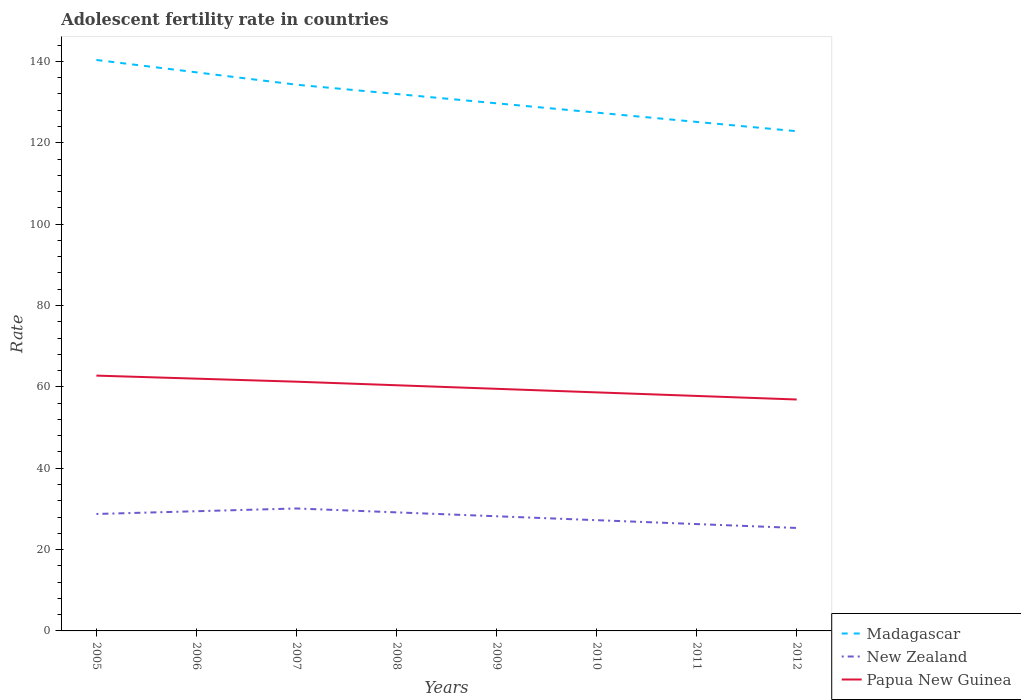Across all years, what is the maximum adolescent fertility rate in New Zealand?
Ensure brevity in your answer.  25.31. In which year was the adolescent fertility rate in Madagascar maximum?
Ensure brevity in your answer.  2012. What is the total adolescent fertility rate in Papua New Guinea in the graph?
Give a very brief answer. 5. What is the difference between the highest and the second highest adolescent fertility rate in Papua New Guinea?
Give a very brief answer. 5.87. Is the adolescent fertility rate in Papua New Guinea strictly greater than the adolescent fertility rate in Madagascar over the years?
Make the answer very short. Yes. How many years are there in the graph?
Make the answer very short. 8. Are the values on the major ticks of Y-axis written in scientific E-notation?
Offer a very short reply. No. Does the graph contain any zero values?
Make the answer very short. No. Does the graph contain grids?
Offer a very short reply. No. Where does the legend appear in the graph?
Provide a succinct answer. Bottom right. How many legend labels are there?
Your response must be concise. 3. How are the legend labels stacked?
Give a very brief answer. Vertical. What is the title of the graph?
Provide a succinct answer. Adolescent fertility rate in countries. What is the label or title of the Y-axis?
Give a very brief answer. Rate. What is the Rate of Madagascar in 2005?
Provide a short and direct response. 140.35. What is the Rate of New Zealand in 2005?
Make the answer very short. 28.75. What is the Rate in Papua New Guinea in 2005?
Offer a very short reply. 62.76. What is the Rate of Madagascar in 2006?
Ensure brevity in your answer.  137.31. What is the Rate of New Zealand in 2006?
Provide a succinct answer. 29.43. What is the Rate of Papua New Guinea in 2006?
Ensure brevity in your answer.  62.02. What is the Rate in Madagascar in 2007?
Give a very brief answer. 134.27. What is the Rate of New Zealand in 2007?
Ensure brevity in your answer.  30.1. What is the Rate of Papua New Guinea in 2007?
Give a very brief answer. 61.27. What is the Rate of Madagascar in 2008?
Provide a succinct answer. 131.99. What is the Rate of New Zealand in 2008?
Your answer should be very brief. 29.14. What is the Rate in Papua New Guinea in 2008?
Offer a terse response. 60.39. What is the Rate in Madagascar in 2009?
Provide a short and direct response. 129.7. What is the Rate of New Zealand in 2009?
Your response must be concise. 28.18. What is the Rate of Papua New Guinea in 2009?
Give a very brief answer. 59.52. What is the Rate of Madagascar in 2010?
Provide a short and direct response. 127.41. What is the Rate of New Zealand in 2010?
Your answer should be very brief. 27.23. What is the Rate in Papua New Guinea in 2010?
Offer a terse response. 58.64. What is the Rate of Madagascar in 2011?
Provide a succinct answer. 125.13. What is the Rate of New Zealand in 2011?
Your answer should be very brief. 26.27. What is the Rate of Papua New Guinea in 2011?
Offer a terse response. 57.76. What is the Rate of Madagascar in 2012?
Make the answer very short. 122.84. What is the Rate of New Zealand in 2012?
Ensure brevity in your answer.  25.31. What is the Rate in Papua New Guinea in 2012?
Your answer should be very brief. 56.89. Across all years, what is the maximum Rate of Madagascar?
Give a very brief answer. 140.35. Across all years, what is the maximum Rate in New Zealand?
Your response must be concise. 30.1. Across all years, what is the maximum Rate of Papua New Guinea?
Provide a short and direct response. 62.76. Across all years, what is the minimum Rate in Madagascar?
Offer a terse response. 122.84. Across all years, what is the minimum Rate of New Zealand?
Keep it short and to the point. 25.31. Across all years, what is the minimum Rate of Papua New Guinea?
Your response must be concise. 56.89. What is the total Rate in Madagascar in the graph?
Your response must be concise. 1049.02. What is the total Rate of New Zealand in the graph?
Offer a terse response. 224.4. What is the total Rate of Papua New Guinea in the graph?
Keep it short and to the point. 479.25. What is the difference between the Rate in Madagascar in 2005 and that in 2006?
Offer a terse response. 3.04. What is the difference between the Rate in New Zealand in 2005 and that in 2006?
Ensure brevity in your answer.  -0.68. What is the difference between the Rate in Papua New Guinea in 2005 and that in 2006?
Your answer should be compact. 0.75. What is the difference between the Rate in Madagascar in 2005 and that in 2007?
Keep it short and to the point. 6.08. What is the difference between the Rate in New Zealand in 2005 and that in 2007?
Make the answer very short. -1.35. What is the difference between the Rate in Papua New Guinea in 2005 and that in 2007?
Provide a succinct answer. 1.49. What is the difference between the Rate in Madagascar in 2005 and that in 2008?
Provide a succinct answer. 8.37. What is the difference between the Rate in New Zealand in 2005 and that in 2008?
Offer a very short reply. -0.39. What is the difference between the Rate of Papua New Guinea in 2005 and that in 2008?
Make the answer very short. 2.37. What is the difference between the Rate in Madagascar in 2005 and that in 2009?
Offer a very short reply. 10.65. What is the difference between the Rate in New Zealand in 2005 and that in 2009?
Your answer should be compact. 0.56. What is the difference between the Rate of Papua New Guinea in 2005 and that in 2009?
Give a very brief answer. 3.25. What is the difference between the Rate of Madagascar in 2005 and that in 2010?
Your answer should be compact. 12.94. What is the difference between the Rate in New Zealand in 2005 and that in 2010?
Make the answer very short. 1.52. What is the difference between the Rate in Papua New Guinea in 2005 and that in 2010?
Your answer should be very brief. 4.12. What is the difference between the Rate in Madagascar in 2005 and that in 2011?
Ensure brevity in your answer.  15.23. What is the difference between the Rate of New Zealand in 2005 and that in 2011?
Offer a terse response. 2.48. What is the difference between the Rate in Papua New Guinea in 2005 and that in 2011?
Give a very brief answer. 5. What is the difference between the Rate in Madagascar in 2005 and that in 2012?
Ensure brevity in your answer.  17.51. What is the difference between the Rate in New Zealand in 2005 and that in 2012?
Keep it short and to the point. 3.44. What is the difference between the Rate of Papua New Guinea in 2005 and that in 2012?
Give a very brief answer. 5.87. What is the difference between the Rate of Madagascar in 2006 and that in 2007?
Ensure brevity in your answer.  3.04. What is the difference between the Rate in New Zealand in 2006 and that in 2007?
Provide a short and direct response. -0.68. What is the difference between the Rate of Papua New Guinea in 2006 and that in 2007?
Make the answer very short. 0.75. What is the difference between the Rate in Madagascar in 2006 and that in 2008?
Your answer should be very brief. 5.33. What is the difference between the Rate of New Zealand in 2006 and that in 2008?
Provide a short and direct response. 0.28. What is the difference between the Rate of Papua New Guinea in 2006 and that in 2008?
Give a very brief answer. 1.62. What is the difference between the Rate in Madagascar in 2006 and that in 2009?
Your response must be concise. 7.61. What is the difference between the Rate in New Zealand in 2006 and that in 2009?
Your answer should be very brief. 1.24. What is the difference between the Rate in Papua New Guinea in 2006 and that in 2009?
Your answer should be very brief. 2.5. What is the difference between the Rate in Madagascar in 2006 and that in 2010?
Ensure brevity in your answer.  9.9. What is the difference between the Rate of New Zealand in 2006 and that in 2010?
Your answer should be very brief. 2.2. What is the difference between the Rate in Papua New Guinea in 2006 and that in 2010?
Offer a very short reply. 3.37. What is the difference between the Rate of Madagascar in 2006 and that in 2011?
Ensure brevity in your answer.  12.19. What is the difference between the Rate in New Zealand in 2006 and that in 2011?
Your response must be concise. 3.16. What is the difference between the Rate of Papua New Guinea in 2006 and that in 2011?
Keep it short and to the point. 4.25. What is the difference between the Rate of Madagascar in 2006 and that in 2012?
Your answer should be very brief. 14.47. What is the difference between the Rate in New Zealand in 2006 and that in 2012?
Provide a succinct answer. 4.12. What is the difference between the Rate of Papua New Guinea in 2006 and that in 2012?
Provide a succinct answer. 5.13. What is the difference between the Rate of Madagascar in 2007 and that in 2008?
Your answer should be very brief. 2.29. What is the difference between the Rate in New Zealand in 2007 and that in 2008?
Your answer should be compact. 0.96. What is the difference between the Rate of Papua New Guinea in 2007 and that in 2008?
Your answer should be very brief. 0.88. What is the difference between the Rate in Madagascar in 2007 and that in 2009?
Your response must be concise. 4.57. What is the difference between the Rate in New Zealand in 2007 and that in 2009?
Ensure brevity in your answer.  1.92. What is the difference between the Rate in Papua New Guinea in 2007 and that in 2009?
Your response must be concise. 1.75. What is the difference between the Rate in Madagascar in 2007 and that in 2010?
Your response must be concise. 6.86. What is the difference between the Rate in New Zealand in 2007 and that in 2010?
Make the answer very short. 2.88. What is the difference between the Rate in Papua New Guinea in 2007 and that in 2010?
Your response must be concise. 2.63. What is the difference between the Rate in Madagascar in 2007 and that in 2011?
Keep it short and to the point. 9.15. What is the difference between the Rate of New Zealand in 2007 and that in 2011?
Provide a succinct answer. 3.83. What is the difference between the Rate of Papua New Guinea in 2007 and that in 2011?
Make the answer very short. 3.5. What is the difference between the Rate of Madagascar in 2007 and that in 2012?
Provide a short and direct response. 11.43. What is the difference between the Rate in New Zealand in 2007 and that in 2012?
Offer a terse response. 4.79. What is the difference between the Rate of Papua New Guinea in 2007 and that in 2012?
Ensure brevity in your answer.  4.38. What is the difference between the Rate of Madagascar in 2008 and that in 2009?
Keep it short and to the point. 2.29. What is the difference between the Rate in New Zealand in 2008 and that in 2009?
Your answer should be compact. 0.96. What is the difference between the Rate of Papua New Guinea in 2008 and that in 2009?
Provide a succinct answer. 0.88. What is the difference between the Rate in Madagascar in 2008 and that in 2010?
Keep it short and to the point. 4.57. What is the difference between the Rate of New Zealand in 2008 and that in 2010?
Your response must be concise. 1.92. What is the difference between the Rate in Papua New Guinea in 2008 and that in 2010?
Your answer should be very brief. 1.75. What is the difference between the Rate of Madagascar in 2008 and that in 2011?
Make the answer very short. 6.86. What is the difference between the Rate of New Zealand in 2008 and that in 2011?
Give a very brief answer. 2.88. What is the difference between the Rate in Papua New Guinea in 2008 and that in 2011?
Provide a succinct answer. 2.63. What is the difference between the Rate in Madagascar in 2008 and that in 2012?
Keep it short and to the point. 9.15. What is the difference between the Rate in New Zealand in 2008 and that in 2012?
Your response must be concise. 3.83. What is the difference between the Rate in Papua New Guinea in 2008 and that in 2012?
Offer a very short reply. 3.5. What is the difference between the Rate of Madagascar in 2009 and that in 2010?
Offer a very short reply. 2.29. What is the difference between the Rate in New Zealand in 2009 and that in 2010?
Your response must be concise. 0.96. What is the difference between the Rate of Papua New Guinea in 2009 and that in 2010?
Give a very brief answer. 0.88. What is the difference between the Rate of Madagascar in 2009 and that in 2011?
Offer a very short reply. 4.57. What is the difference between the Rate in New Zealand in 2009 and that in 2011?
Offer a terse response. 1.92. What is the difference between the Rate of Papua New Guinea in 2009 and that in 2011?
Offer a very short reply. 1.75. What is the difference between the Rate in Madagascar in 2009 and that in 2012?
Provide a succinct answer. 6.86. What is the difference between the Rate in New Zealand in 2009 and that in 2012?
Offer a terse response. 2.88. What is the difference between the Rate of Papua New Guinea in 2009 and that in 2012?
Your answer should be compact. 2.63. What is the difference between the Rate in Madagascar in 2010 and that in 2011?
Keep it short and to the point. 2.29. What is the difference between the Rate of New Zealand in 2010 and that in 2011?
Keep it short and to the point. 0.96. What is the difference between the Rate in Papua New Guinea in 2010 and that in 2011?
Ensure brevity in your answer.  0.88. What is the difference between the Rate of Madagascar in 2010 and that in 2012?
Your answer should be compact. 4.57. What is the difference between the Rate in New Zealand in 2010 and that in 2012?
Make the answer very short. 1.92. What is the difference between the Rate in Papua New Guinea in 2010 and that in 2012?
Provide a succinct answer. 1.75. What is the difference between the Rate in Madagascar in 2011 and that in 2012?
Your answer should be very brief. 2.29. What is the difference between the Rate of New Zealand in 2011 and that in 2012?
Offer a very short reply. 0.96. What is the difference between the Rate of Papua New Guinea in 2011 and that in 2012?
Provide a short and direct response. 0.88. What is the difference between the Rate in Madagascar in 2005 and the Rate in New Zealand in 2006?
Ensure brevity in your answer.  110.93. What is the difference between the Rate of Madagascar in 2005 and the Rate of Papua New Guinea in 2006?
Give a very brief answer. 78.34. What is the difference between the Rate of New Zealand in 2005 and the Rate of Papua New Guinea in 2006?
Offer a terse response. -33.27. What is the difference between the Rate of Madagascar in 2005 and the Rate of New Zealand in 2007?
Give a very brief answer. 110.25. What is the difference between the Rate in Madagascar in 2005 and the Rate in Papua New Guinea in 2007?
Ensure brevity in your answer.  79.09. What is the difference between the Rate in New Zealand in 2005 and the Rate in Papua New Guinea in 2007?
Provide a succinct answer. -32.52. What is the difference between the Rate in Madagascar in 2005 and the Rate in New Zealand in 2008?
Your answer should be very brief. 111.21. What is the difference between the Rate of Madagascar in 2005 and the Rate of Papua New Guinea in 2008?
Your response must be concise. 79.96. What is the difference between the Rate of New Zealand in 2005 and the Rate of Papua New Guinea in 2008?
Make the answer very short. -31.64. What is the difference between the Rate of Madagascar in 2005 and the Rate of New Zealand in 2009?
Give a very brief answer. 112.17. What is the difference between the Rate of Madagascar in 2005 and the Rate of Papua New Guinea in 2009?
Offer a very short reply. 80.84. What is the difference between the Rate of New Zealand in 2005 and the Rate of Papua New Guinea in 2009?
Keep it short and to the point. -30.77. What is the difference between the Rate in Madagascar in 2005 and the Rate in New Zealand in 2010?
Ensure brevity in your answer.  113.13. What is the difference between the Rate of Madagascar in 2005 and the Rate of Papua New Guinea in 2010?
Offer a very short reply. 81.71. What is the difference between the Rate of New Zealand in 2005 and the Rate of Papua New Guinea in 2010?
Your response must be concise. -29.89. What is the difference between the Rate in Madagascar in 2005 and the Rate in New Zealand in 2011?
Your answer should be very brief. 114.09. What is the difference between the Rate of Madagascar in 2005 and the Rate of Papua New Guinea in 2011?
Offer a terse response. 82.59. What is the difference between the Rate in New Zealand in 2005 and the Rate in Papua New Guinea in 2011?
Keep it short and to the point. -29.02. What is the difference between the Rate in Madagascar in 2005 and the Rate in New Zealand in 2012?
Your response must be concise. 115.04. What is the difference between the Rate of Madagascar in 2005 and the Rate of Papua New Guinea in 2012?
Your response must be concise. 83.46. What is the difference between the Rate in New Zealand in 2005 and the Rate in Papua New Guinea in 2012?
Your answer should be very brief. -28.14. What is the difference between the Rate in Madagascar in 2006 and the Rate in New Zealand in 2007?
Your answer should be compact. 107.21. What is the difference between the Rate of Madagascar in 2006 and the Rate of Papua New Guinea in 2007?
Provide a succinct answer. 76.05. What is the difference between the Rate in New Zealand in 2006 and the Rate in Papua New Guinea in 2007?
Give a very brief answer. -31.84. What is the difference between the Rate in Madagascar in 2006 and the Rate in New Zealand in 2008?
Provide a succinct answer. 108.17. What is the difference between the Rate of Madagascar in 2006 and the Rate of Papua New Guinea in 2008?
Make the answer very short. 76.92. What is the difference between the Rate in New Zealand in 2006 and the Rate in Papua New Guinea in 2008?
Make the answer very short. -30.97. What is the difference between the Rate of Madagascar in 2006 and the Rate of New Zealand in 2009?
Ensure brevity in your answer.  109.13. What is the difference between the Rate of Madagascar in 2006 and the Rate of Papua New Guinea in 2009?
Provide a succinct answer. 77.8. What is the difference between the Rate of New Zealand in 2006 and the Rate of Papua New Guinea in 2009?
Provide a short and direct response. -30.09. What is the difference between the Rate in Madagascar in 2006 and the Rate in New Zealand in 2010?
Give a very brief answer. 110.09. What is the difference between the Rate of Madagascar in 2006 and the Rate of Papua New Guinea in 2010?
Your answer should be compact. 78.67. What is the difference between the Rate of New Zealand in 2006 and the Rate of Papua New Guinea in 2010?
Make the answer very short. -29.22. What is the difference between the Rate of Madagascar in 2006 and the Rate of New Zealand in 2011?
Offer a very short reply. 111.05. What is the difference between the Rate of Madagascar in 2006 and the Rate of Papua New Guinea in 2011?
Ensure brevity in your answer.  79.55. What is the difference between the Rate of New Zealand in 2006 and the Rate of Papua New Guinea in 2011?
Your answer should be very brief. -28.34. What is the difference between the Rate in Madagascar in 2006 and the Rate in New Zealand in 2012?
Your answer should be compact. 112. What is the difference between the Rate in Madagascar in 2006 and the Rate in Papua New Guinea in 2012?
Make the answer very short. 80.42. What is the difference between the Rate in New Zealand in 2006 and the Rate in Papua New Guinea in 2012?
Your answer should be very brief. -27.46. What is the difference between the Rate in Madagascar in 2007 and the Rate in New Zealand in 2008?
Keep it short and to the point. 105.13. What is the difference between the Rate in Madagascar in 2007 and the Rate in Papua New Guinea in 2008?
Make the answer very short. 73.88. What is the difference between the Rate in New Zealand in 2007 and the Rate in Papua New Guinea in 2008?
Your answer should be very brief. -30.29. What is the difference between the Rate in Madagascar in 2007 and the Rate in New Zealand in 2009?
Ensure brevity in your answer.  106.09. What is the difference between the Rate in Madagascar in 2007 and the Rate in Papua New Guinea in 2009?
Offer a very short reply. 74.76. What is the difference between the Rate of New Zealand in 2007 and the Rate of Papua New Guinea in 2009?
Make the answer very short. -29.42. What is the difference between the Rate of Madagascar in 2007 and the Rate of New Zealand in 2010?
Offer a terse response. 107.05. What is the difference between the Rate of Madagascar in 2007 and the Rate of Papua New Guinea in 2010?
Your response must be concise. 75.63. What is the difference between the Rate of New Zealand in 2007 and the Rate of Papua New Guinea in 2010?
Your answer should be compact. -28.54. What is the difference between the Rate of Madagascar in 2007 and the Rate of New Zealand in 2011?
Keep it short and to the point. 108.01. What is the difference between the Rate in Madagascar in 2007 and the Rate in Papua New Guinea in 2011?
Offer a terse response. 76.51. What is the difference between the Rate in New Zealand in 2007 and the Rate in Papua New Guinea in 2011?
Your response must be concise. -27.66. What is the difference between the Rate in Madagascar in 2007 and the Rate in New Zealand in 2012?
Your response must be concise. 108.97. What is the difference between the Rate of Madagascar in 2007 and the Rate of Papua New Guinea in 2012?
Your answer should be very brief. 77.39. What is the difference between the Rate of New Zealand in 2007 and the Rate of Papua New Guinea in 2012?
Make the answer very short. -26.79. What is the difference between the Rate in Madagascar in 2008 and the Rate in New Zealand in 2009?
Provide a short and direct response. 103.8. What is the difference between the Rate in Madagascar in 2008 and the Rate in Papua New Guinea in 2009?
Your response must be concise. 72.47. What is the difference between the Rate in New Zealand in 2008 and the Rate in Papua New Guinea in 2009?
Provide a short and direct response. -30.37. What is the difference between the Rate of Madagascar in 2008 and the Rate of New Zealand in 2010?
Make the answer very short. 104.76. What is the difference between the Rate in Madagascar in 2008 and the Rate in Papua New Guinea in 2010?
Your answer should be compact. 73.35. What is the difference between the Rate of New Zealand in 2008 and the Rate of Papua New Guinea in 2010?
Ensure brevity in your answer.  -29.5. What is the difference between the Rate in Madagascar in 2008 and the Rate in New Zealand in 2011?
Provide a short and direct response. 105.72. What is the difference between the Rate in Madagascar in 2008 and the Rate in Papua New Guinea in 2011?
Offer a very short reply. 74.22. What is the difference between the Rate of New Zealand in 2008 and the Rate of Papua New Guinea in 2011?
Your answer should be very brief. -28.62. What is the difference between the Rate of Madagascar in 2008 and the Rate of New Zealand in 2012?
Your answer should be very brief. 106.68. What is the difference between the Rate of Madagascar in 2008 and the Rate of Papua New Guinea in 2012?
Your response must be concise. 75.1. What is the difference between the Rate in New Zealand in 2008 and the Rate in Papua New Guinea in 2012?
Your answer should be very brief. -27.75. What is the difference between the Rate in Madagascar in 2009 and the Rate in New Zealand in 2010?
Offer a very short reply. 102.48. What is the difference between the Rate of Madagascar in 2009 and the Rate of Papua New Guinea in 2010?
Give a very brief answer. 71.06. What is the difference between the Rate of New Zealand in 2009 and the Rate of Papua New Guinea in 2010?
Your answer should be very brief. -30.46. What is the difference between the Rate of Madagascar in 2009 and the Rate of New Zealand in 2011?
Provide a succinct answer. 103.43. What is the difference between the Rate in Madagascar in 2009 and the Rate in Papua New Guinea in 2011?
Provide a succinct answer. 71.94. What is the difference between the Rate of New Zealand in 2009 and the Rate of Papua New Guinea in 2011?
Your response must be concise. -29.58. What is the difference between the Rate in Madagascar in 2009 and the Rate in New Zealand in 2012?
Offer a very short reply. 104.39. What is the difference between the Rate of Madagascar in 2009 and the Rate of Papua New Guinea in 2012?
Your response must be concise. 72.81. What is the difference between the Rate of New Zealand in 2009 and the Rate of Papua New Guinea in 2012?
Your response must be concise. -28.7. What is the difference between the Rate in Madagascar in 2010 and the Rate in New Zealand in 2011?
Offer a very short reply. 101.15. What is the difference between the Rate of Madagascar in 2010 and the Rate of Papua New Guinea in 2011?
Provide a succinct answer. 69.65. What is the difference between the Rate of New Zealand in 2010 and the Rate of Papua New Guinea in 2011?
Keep it short and to the point. -30.54. What is the difference between the Rate of Madagascar in 2010 and the Rate of New Zealand in 2012?
Your answer should be compact. 102.11. What is the difference between the Rate of Madagascar in 2010 and the Rate of Papua New Guinea in 2012?
Offer a terse response. 70.53. What is the difference between the Rate of New Zealand in 2010 and the Rate of Papua New Guinea in 2012?
Your answer should be compact. -29.66. What is the difference between the Rate in Madagascar in 2011 and the Rate in New Zealand in 2012?
Make the answer very short. 99.82. What is the difference between the Rate in Madagascar in 2011 and the Rate in Papua New Guinea in 2012?
Provide a succinct answer. 68.24. What is the difference between the Rate of New Zealand in 2011 and the Rate of Papua New Guinea in 2012?
Your answer should be very brief. -30.62. What is the average Rate of Madagascar per year?
Make the answer very short. 131.13. What is the average Rate of New Zealand per year?
Your answer should be compact. 28.05. What is the average Rate of Papua New Guinea per year?
Provide a succinct answer. 59.91. In the year 2005, what is the difference between the Rate of Madagascar and Rate of New Zealand?
Provide a short and direct response. 111.6. In the year 2005, what is the difference between the Rate of Madagascar and Rate of Papua New Guinea?
Offer a terse response. 77.59. In the year 2005, what is the difference between the Rate in New Zealand and Rate in Papua New Guinea?
Offer a terse response. -34.01. In the year 2006, what is the difference between the Rate in Madagascar and Rate in New Zealand?
Make the answer very short. 107.89. In the year 2006, what is the difference between the Rate in Madagascar and Rate in Papua New Guinea?
Keep it short and to the point. 75.3. In the year 2006, what is the difference between the Rate of New Zealand and Rate of Papua New Guinea?
Your response must be concise. -32.59. In the year 2007, what is the difference between the Rate in Madagascar and Rate in New Zealand?
Provide a succinct answer. 104.17. In the year 2007, what is the difference between the Rate of Madagascar and Rate of Papua New Guinea?
Make the answer very short. 73.01. In the year 2007, what is the difference between the Rate of New Zealand and Rate of Papua New Guinea?
Make the answer very short. -31.17. In the year 2008, what is the difference between the Rate in Madagascar and Rate in New Zealand?
Your response must be concise. 102.84. In the year 2008, what is the difference between the Rate in Madagascar and Rate in Papua New Guinea?
Provide a short and direct response. 71.6. In the year 2008, what is the difference between the Rate of New Zealand and Rate of Papua New Guinea?
Ensure brevity in your answer.  -31.25. In the year 2009, what is the difference between the Rate of Madagascar and Rate of New Zealand?
Offer a terse response. 101.52. In the year 2009, what is the difference between the Rate in Madagascar and Rate in Papua New Guinea?
Provide a short and direct response. 70.18. In the year 2009, what is the difference between the Rate in New Zealand and Rate in Papua New Guinea?
Keep it short and to the point. -31.33. In the year 2010, what is the difference between the Rate in Madagascar and Rate in New Zealand?
Make the answer very short. 100.19. In the year 2010, what is the difference between the Rate in Madagascar and Rate in Papua New Guinea?
Offer a very short reply. 68.77. In the year 2010, what is the difference between the Rate of New Zealand and Rate of Papua New Guinea?
Offer a very short reply. -31.41. In the year 2011, what is the difference between the Rate of Madagascar and Rate of New Zealand?
Your response must be concise. 98.86. In the year 2011, what is the difference between the Rate in Madagascar and Rate in Papua New Guinea?
Offer a very short reply. 67.36. In the year 2011, what is the difference between the Rate in New Zealand and Rate in Papua New Guinea?
Provide a short and direct response. -31.5. In the year 2012, what is the difference between the Rate in Madagascar and Rate in New Zealand?
Offer a terse response. 97.53. In the year 2012, what is the difference between the Rate of Madagascar and Rate of Papua New Guinea?
Offer a very short reply. 65.95. In the year 2012, what is the difference between the Rate of New Zealand and Rate of Papua New Guinea?
Ensure brevity in your answer.  -31.58. What is the ratio of the Rate of Madagascar in 2005 to that in 2006?
Keep it short and to the point. 1.02. What is the ratio of the Rate in Papua New Guinea in 2005 to that in 2006?
Provide a short and direct response. 1.01. What is the ratio of the Rate of Madagascar in 2005 to that in 2007?
Your answer should be very brief. 1.05. What is the ratio of the Rate of New Zealand in 2005 to that in 2007?
Give a very brief answer. 0.96. What is the ratio of the Rate of Papua New Guinea in 2005 to that in 2007?
Make the answer very short. 1.02. What is the ratio of the Rate of Madagascar in 2005 to that in 2008?
Provide a succinct answer. 1.06. What is the ratio of the Rate in New Zealand in 2005 to that in 2008?
Your response must be concise. 0.99. What is the ratio of the Rate of Papua New Guinea in 2005 to that in 2008?
Your response must be concise. 1.04. What is the ratio of the Rate in Madagascar in 2005 to that in 2009?
Offer a very short reply. 1.08. What is the ratio of the Rate of New Zealand in 2005 to that in 2009?
Provide a succinct answer. 1.02. What is the ratio of the Rate of Papua New Guinea in 2005 to that in 2009?
Ensure brevity in your answer.  1.05. What is the ratio of the Rate in Madagascar in 2005 to that in 2010?
Give a very brief answer. 1.1. What is the ratio of the Rate in New Zealand in 2005 to that in 2010?
Make the answer very short. 1.06. What is the ratio of the Rate in Papua New Guinea in 2005 to that in 2010?
Your response must be concise. 1.07. What is the ratio of the Rate of Madagascar in 2005 to that in 2011?
Ensure brevity in your answer.  1.12. What is the ratio of the Rate in New Zealand in 2005 to that in 2011?
Provide a short and direct response. 1.09. What is the ratio of the Rate in Papua New Guinea in 2005 to that in 2011?
Your response must be concise. 1.09. What is the ratio of the Rate in Madagascar in 2005 to that in 2012?
Provide a short and direct response. 1.14. What is the ratio of the Rate in New Zealand in 2005 to that in 2012?
Keep it short and to the point. 1.14. What is the ratio of the Rate of Papua New Guinea in 2005 to that in 2012?
Your response must be concise. 1.1. What is the ratio of the Rate of Madagascar in 2006 to that in 2007?
Keep it short and to the point. 1.02. What is the ratio of the Rate in New Zealand in 2006 to that in 2007?
Keep it short and to the point. 0.98. What is the ratio of the Rate of Papua New Guinea in 2006 to that in 2007?
Your answer should be compact. 1.01. What is the ratio of the Rate of Madagascar in 2006 to that in 2008?
Offer a very short reply. 1.04. What is the ratio of the Rate of New Zealand in 2006 to that in 2008?
Provide a succinct answer. 1.01. What is the ratio of the Rate of Papua New Guinea in 2006 to that in 2008?
Make the answer very short. 1.03. What is the ratio of the Rate in Madagascar in 2006 to that in 2009?
Offer a terse response. 1.06. What is the ratio of the Rate in New Zealand in 2006 to that in 2009?
Provide a succinct answer. 1.04. What is the ratio of the Rate of Papua New Guinea in 2006 to that in 2009?
Your answer should be compact. 1.04. What is the ratio of the Rate in Madagascar in 2006 to that in 2010?
Ensure brevity in your answer.  1.08. What is the ratio of the Rate of New Zealand in 2006 to that in 2010?
Your answer should be compact. 1.08. What is the ratio of the Rate in Papua New Guinea in 2006 to that in 2010?
Your answer should be compact. 1.06. What is the ratio of the Rate of Madagascar in 2006 to that in 2011?
Give a very brief answer. 1.1. What is the ratio of the Rate in New Zealand in 2006 to that in 2011?
Your answer should be compact. 1.12. What is the ratio of the Rate in Papua New Guinea in 2006 to that in 2011?
Make the answer very short. 1.07. What is the ratio of the Rate of Madagascar in 2006 to that in 2012?
Ensure brevity in your answer.  1.12. What is the ratio of the Rate of New Zealand in 2006 to that in 2012?
Make the answer very short. 1.16. What is the ratio of the Rate in Papua New Guinea in 2006 to that in 2012?
Your response must be concise. 1.09. What is the ratio of the Rate in Madagascar in 2007 to that in 2008?
Your response must be concise. 1.02. What is the ratio of the Rate in New Zealand in 2007 to that in 2008?
Provide a succinct answer. 1.03. What is the ratio of the Rate in Papua New Guinea in 2007 to that in 2008?
Your response must be concise. 1.01. What is the ratio of the Rate in Madagascar in 2007 to that in 2009?
Your answer should be compact. 1.04. What is the ratio of the Rate in New Zealand in 2007 to that in 2009?
Provide a succinct answer. 1.07. What is the ratio of the Rate of Papua New Guinea in 2007 to that in 2009?
Provide a succinct answer. 1.03. What is the ratio of the Rate in Madagascar in 2007 to that in 2010?
Make the answer very short. 1.05. What is the ratio of the Rate in New Zealand in 2007 to that in 2010?
Your answer should be compact. 1.11. What is the ratio of the Rate of Papua New Guinea in 2007 to that in 2010?
Offer a terse response. 1.04. What is the ratio of the Rate of Madagascar in 2007 to that in 2011?
Keep it short and to the point. 1.07. What is the ratio of the Rate of New Zealand in 2007 to that in 2011?
Offer a terse response. 1.15. What is the ratio of the Rate of Papua New Guinea in 2007 to that in 2011?
Make the answer very short. 1.06. What is the ratio of the Rate in Madagascar in 2007 to that in 2012?
Your response must be concise. 1.09. What is the ratio of the Rate in New Zealand in 2007 to that in 2012?
Provide a succinct answer. 1.19. What is the ratio of the Rate of Papua New Guinea in 2007 to that in 2012?
Provide a short and direct response. 1.08. What is the ratio of the Rate of Madagascar in 2008 to that in 2009?
Give a very brief answer. 1.02. What is the ratio of the Rate of New Zealand in 2008 to that in 2009?
Offer a very short reply. 1.03. What is the ratio of the Rate of Papua New Guinea in 2008 to that in 2009?
Provide a short and direct response. 1.01. What is the ratio of the Rate of Madagascar in 2008 to that in 2010?
Your answer should be very brief. 1.04. What is the ratio of the Rate of New Zealand in 2008 to that in 2010?
Give a very brief answer. 1.07. What is the ratio of the Rate of Papua New Guinea in 2008 to that in 2010?
Offer a terse response. 1.03. What is the ratio of the Rate of Madagascar in 2008 to that in 2011?
Your answer should be very brief. 1.05. What is the ratio of the Rate in New Zealand in 2008 to that in 2011?
Make the answer very short. 1.11. What is the ratio of the Rate in Papua New Guinea in 2008 to that in 2011?
Your answer should be very brief. 1.05. What is the ratio of the Rate of Madagascar in 2008 to that in 2012?
Give a very brief answer. 1.07. What is the ratio of the Rate of New Zealand in 2008 to that in 2012?
Ensure brevity in your answer.  1.15. What is the ratio of the Rate in Papua New Guinea in 2008 to that in 2012?
Your answer should be compact. 1.06. What is the ratio of the Rate in Madagascar in 2009 to that in 2010?
Ensure brevity in your answer.  1.02. What is the ratio of the Rate in New Zealand in 2009 to that in 2010?
Your answer should be compact. 1.04. What is the ratio of the Rate of Papua New Guinea in 2009 to that in 2010?
Make the answer very short. 1.01. What is the ratio of the Rate in Madagascar in 2009 to that in 2011?
Keep it short and to the point. 1.04. What is the ratio of the Rate in New Zealand in 2009 to that in 2011?
Ensure brevity in your answer.  1.07. What is the ratio of the Rate in Papua New Guinea in 2009 to that in 2011?
Provide a short and direct response. 1.03. What is the ratio of the Rate of Madagascar in 2009 to that in 2012?
Give a very brief answer. 1.06. What is the ratio of the Rate of New Zealand in 2009 to that in 2012?
Provide a short and direct response. 1.11. What is the ratio of the Rate in Papua New Guinea in 2009 to that in 2012?
Offer a very short reply. 1.05. What is the ratio of the Rate in Madagascar in 2010 to that in 2011?
Provide a short and direct response. 1.02. What is the ratio of the Rate in New Zealand in 2010 to that in 2011?
Offer a terse response. 1.04. What is the ratio of the Rate of Papua New Guinea in 2010 to that in 2011?
Keep it short and to the point. 1.02. What is the ratio of the Rate of Madagascar in 2010 to that in 2012?
Ensure brevity in your answer.  1.04. What is the ratio of the Rate in New Zealand in 2010 to that in 2012?
Ensure brevity in your answer.  1.08. What is the ratio of the Rate of Papua New Guinea in 2010 to that in 2012?
Offer a very short reply. 1.03. What is the ratio of the Rate in Madagascar in 2011 to that in 2012?
Make the answer very short. 1.02. What is the ratio of the Rate of New Zealand in 2011 to that in 2012?
Your answer should be compact. 1.04. What is the ratio of the Rate in Papua New Guinea in 2011 to that in 2012?
Your answer should be compact. 1.02. What is the difference between the highest and the second highest Rate of Madagascar?
Your response must be concise. 3.04. What is the difference between the highest and the second highest Rate of New Zealand?
Make the answer very short. 0.68. What is the difference between the highest and the second highest Rate of Papua New Guinea?
Give a very brief answer. 0.75. What is the difference between the highest and the lowest Rate of Madagascar?
Offer a very short reply. 17.51. What is the difference between the highest and the lowest Rate of New Zealand?
Give a very brief answer. 4.79. What is the difference between the highest and the lowest Rate of Papua New Guinea?
Keep it short and to the point. 5.87. 